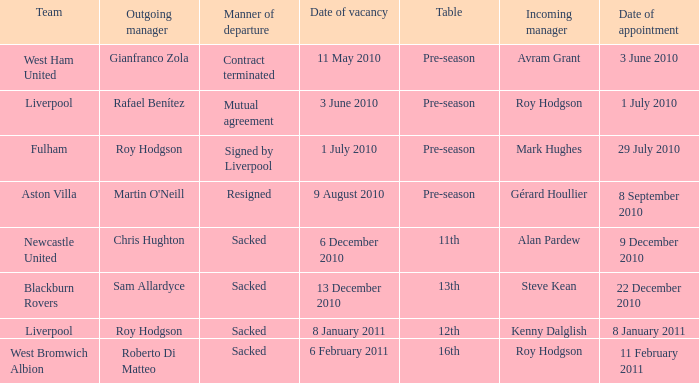What was the date of appointment for incoming manager Roy Hodgson and the team is Liverpool? 1 July 2010. 